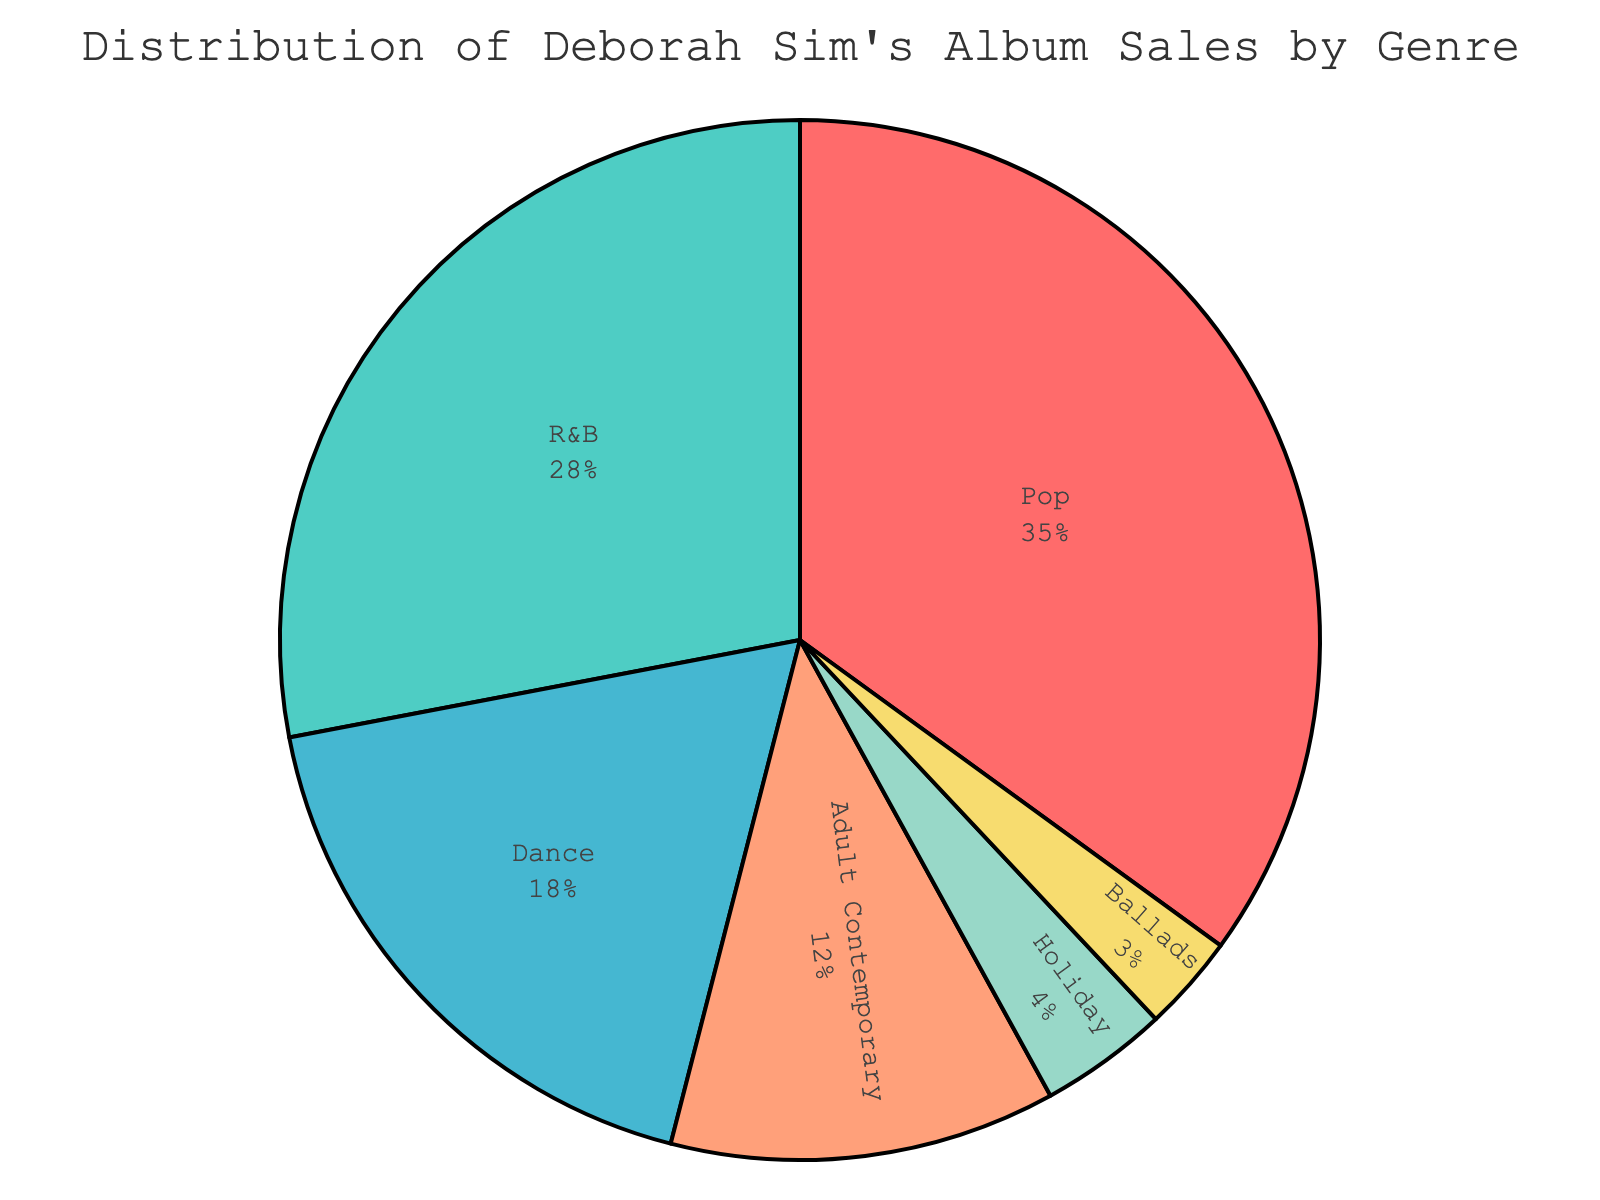Which genre has the highest percentage of album sales? The genre with the largest slice in the pie chart and the highest percentage label is Pop.
Answer: Pop What's the combined sales percentage of Pop and R&B albums? The sales percentages for Pop and R&B are 35% and 28%, respectively. Add them together: 35 + 28 = 63%
Answer: 63% Is the sales percentage of Dance albums greater than that of Ballads and Holiday albums combined? The sales percentage for Dance is 18%. Ballads and Holiday contribute 3% and 4% respectively, which together make 3 + 4 = 7%. 18% > 7%.
Answer: Yes What is the difference in sales percentage between Pop and Adult Contemporary albums? The sales percentage for Pop is 35% and for Adult Contemporary it’s 12%. Subtract the latter from the former: 35 - 12 = 23%.
Answer: 23% How do the sales percentages of R&B and Dance compare? R&B's sales percentage is 28% and Dance's is 18%. Compare 28% to 18%, 28% is greater than 18%.
Answer: R&B is greater What percentage of the album sales come from genres other than Pop and R&B? Pop and R&B together sum up to 63%. Subtract this from 100% to find other genres: 100 - 63 = 37%.
Answer: 37% Which genre has the smallest share of album sales? The genre with the smallest slice and percentage label in the pie chart is Ballads, which has 3%.
Answer: Ballads If we group Adult Contemporary and Holiday together, what would their combined sales percentage be? Adult Contemporary has 12% and Holiday has 4%. Add them together: 12 + 4 = 16%.
Answer: 16% Are the combined sales percentages of Ballads and Holiday albums less than that of Dance albums? The combined percentage for Ballads and Holiday is 3 + 4 = 7%. The sales percentage for Dance is 18%. Comparing the two, 7 < 18.
Answer: Yes, less What proportion of the sales is attributed to Adult Contemporary versus Dance? Adult Contemporary has a sales percentage of 12%, while Dance has 18%. To find the proportion of Adult Contemporary to Dance, divide their percentages: 12 / 18 = 2 / 3 or approximately 66.67%.
Answer: 2:3 or approximately 66.67% 